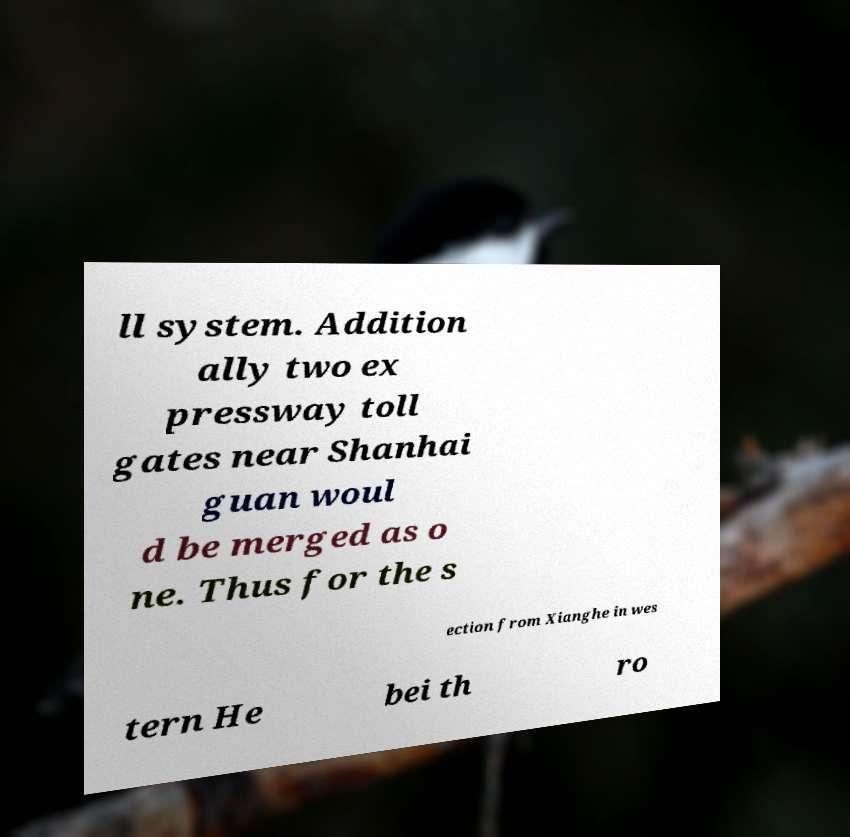What messages or text are displayed in this image? I need them in a readable, typed format. ll system. Addition ally two ex pressway toll gates near Shanhai guan woul d be merged as o ne. Thus for the s ection from Xianghe in wes tern He bei th ro 